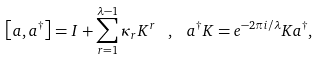Convert formula to latex. <formula><loc_0><loc_0><loc_500><loc_500>\left [ a , a ^ { \dagger } \right ] = I + \sum _ { r = 1 } ^ { \lambda - 1 } { \kappa } _ { r } { K } ^ { r } \, \ , \, \ a ^ { \dagger } K = e ^ { - 2 \pi i / \lambda } K a ^ { \dagger } ,</formula> 